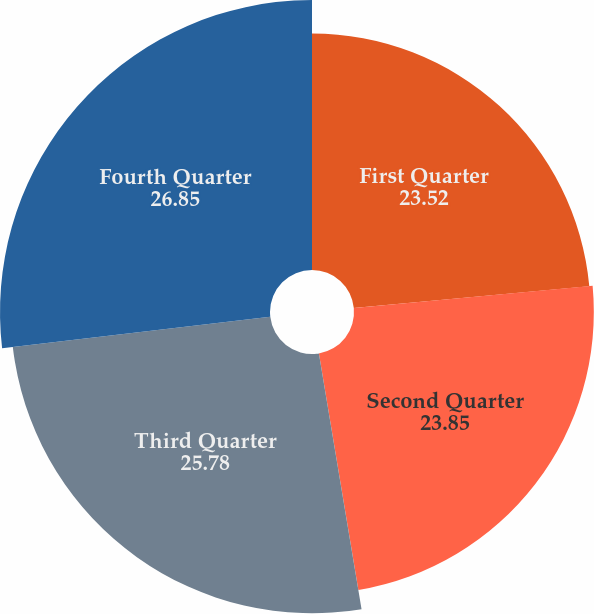Convert chart. <chart><loc_0><loc_0><loc_500><loc_500><pie_chart><fcel>First Quarter<fcel>Second Quarter<fcel>Third Quarter<fcel>Fourth Quarter<nl><fcel>23.52%<fcel>23.85%<fcel>25.78%<fcel>26.85%<nl></chart> 